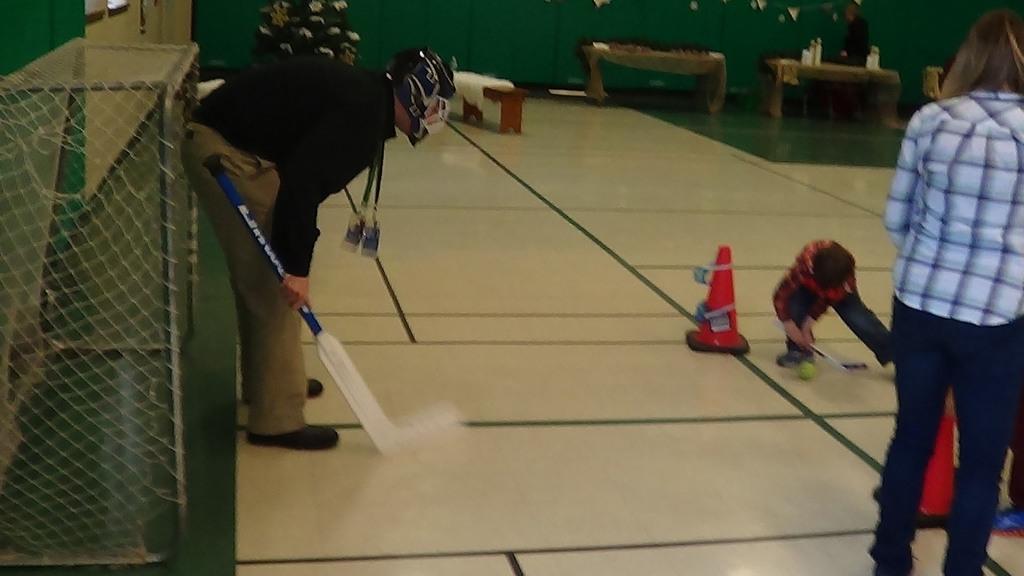In one or two sentences, can you explain what this image depicts? This picture consists of a person holding a bat, wearing helmet visible on in front of net on the left side, in the middle I can see a boy and women and tables in front of table I can see a person,at the top I can see green color fence 